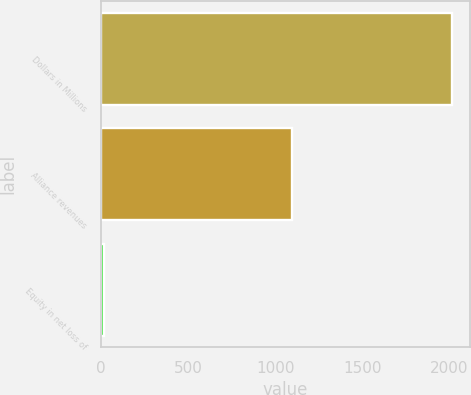Convert chart to OTSL. <chart><loc_0><loc_0><loc_500><loc_500><bar_chart><fcel>Dollars in Millions<fcel>Alliance revenues<fcel>Equity in net loss of<nl><fcel>2015<fcel>1096<fcel>17<nl></chart> 